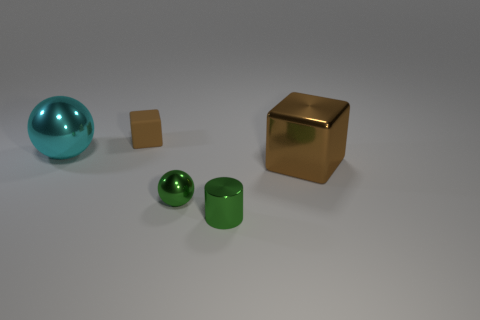Add 4 big purple balls. How many objects exist? 9 Subtract all cylinders. How many objects are left? 4 Subtract all rubber things. Subtract all tiny brown matte cubes. How many objects are left? 3 Add 2 small balls. How many small balls are left? 3 Add 3 rubber blocks. How many rubber blocks exist? 4 Subtract 0 green blocks. How many objects are left? 5 